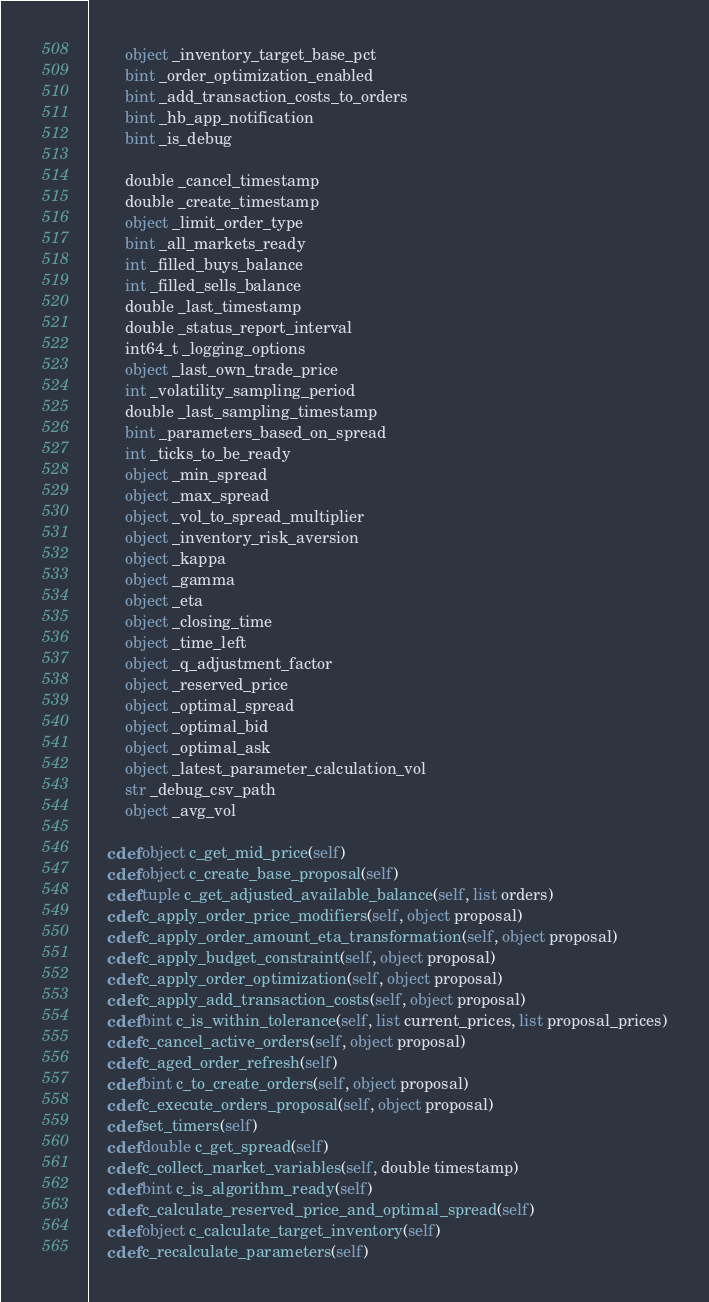<code> <loc_0><loc_0><loc_500><loc_500><_Cython_>        object _inventory_target_base_pct
        bint _order_optimization_enabled
        bint _add_transaction_costs_to_orders
        bint _hb_app_notification
        bint _is_debug

        double _cancel_timestamp
        double _create_timestamp
        object _limit_order_type
        bint _all_markets_ready
        int _filled_buys_balance
        int _filled_sells_balance
        double _last_timestamp
        double _status_report_interval
        int64_t _logging_options
        object _last_own_trade_price
        int _volatility_sampling_period
        double _last_sampling_timestamp
        bint _parameters_based_on_spread
        int _ticks_to_be_ready
        object _min_spread
        object _max_spread
        object _vol_to_spread_multiplier
        object _inventory_risk_aversion
        object _kappa
        object _gamma
        object _eta
        object _closing_time
        object _time_left
        object _q_adjustment_factor
        object _reserved_price
        object _optimal_spread
        object _optimal_bid
        object _optimal_ask
        object _latest_parameter_calculation_vol
        str _debug_csv_path
        object _avg_vol

    cdef object c_get_mid_price(self)
    cdef object c_create_base_proposal(self)
    cdef tuple c_get_adjusted_available_balance(self, list orders)
    cdef c_apply_order_price_modifiers(self, object proposal)
    cdef c_apply_order_amount_eta_transformation(self, object proposal)
    cdef c_apply_budget_constraint(self, object proposal)
    cdef c_apply_order_optimization(self, object proposal)
    cdef c_apply_add_transaction_costs(self, object proposal)
    cdef bint c_is_within_tolerance(self, list current_prices, list proposal_prices)
    cdef c_cancel_active_orders(self, object proposal)
    cdef c_aged_order_refresh(self)
    cdef bint c_to_create_orders(self, object proposal)
    cdef c_execute_orders_proposal(self, object proposal)
    cdef set_timers(self)
    cdef double c_get_spread(self)
    cdef c_collect_market_variables(self, double timestamp)
    cdef bint c_is_algorithm_ready(self)
    cdef c_calculate_reserved_price_and_optimal_spread(self)
    cdef object c_calculate_target_inventory(self)
    cdef c_recalculate_parameters(self)
</code> 